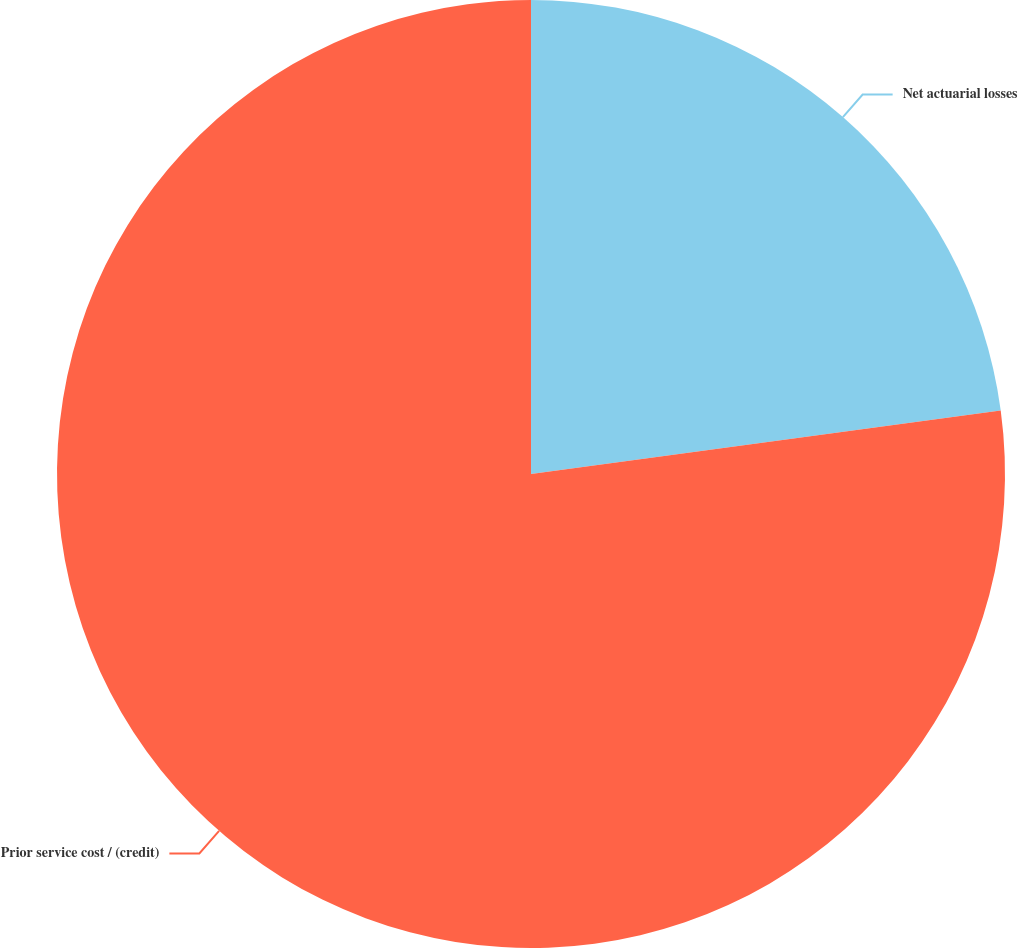Convert chart to OTSL. <chart><loc_0><loc_0><loc_500><loc_500><pie_chart><fcel>Net actuarial losses<fcel>Prior service cost / (credit)<nl><fcel>22.86%<fcel>77.14%<nl></chart> 